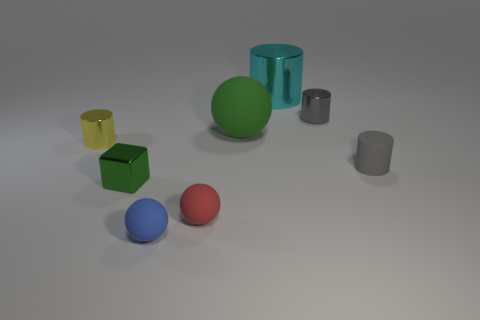What number of other objects are there of the same size as the block?
Provide a short and direct response. 5. How many objects are matte objects that are behind the tiny blue ball or small objects on the right side of the tiny gray metallic object?
Your answer should be very brief. 3. How many tiny metallic things have the same shape as the small blue rubber object?
Provide a short and direct response. 0. There is a tiny object that is behind the tiny matte cylinder and on the left side of the large cyan shiny cylinder; what material is it?
Offer a very short reply. Metal. There is a small blue rubber object; what number of small gray shiny cylinders are in front of it?
Make the answer very short. 0. What number of red things are there?
Offer a terse response. 1. Is the size of the matte cylinder the same as the cyan object?
Ensure brevity in your answer.  No. There is a small gray cylinder in front of the rubber sphere that is behind the gray rubber cylinder; are there any tiny green cubes to the right of it?
Provide a short and direct response. No. What is the material of the cyan thing that is the same shape as the small gray metal thing?
Offer a very short reply. Metal. The tiny cylinder that is right of the tiny gray metal cylinder is what color?
Keep it short and to the point. Gray. 